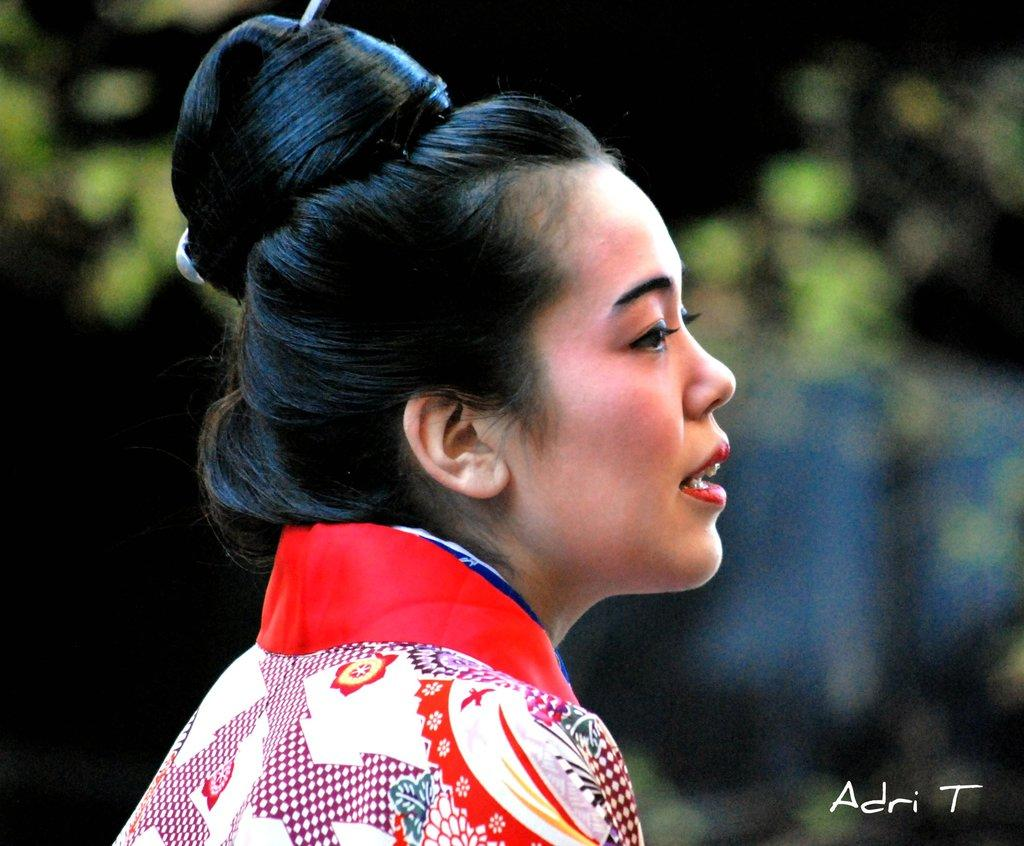Who is present in the image? There is a woman in the image. What can be found at the bottom of the image? There is text at the bottom of the image. How would you describe the background of the image? The background of the image is blurred. How many sheep are visible in the image? There are no sheep present in the image. What type of stitch is used to create the text at the bottom of the image? The image does not provide information about the type of stitch used for the text. 